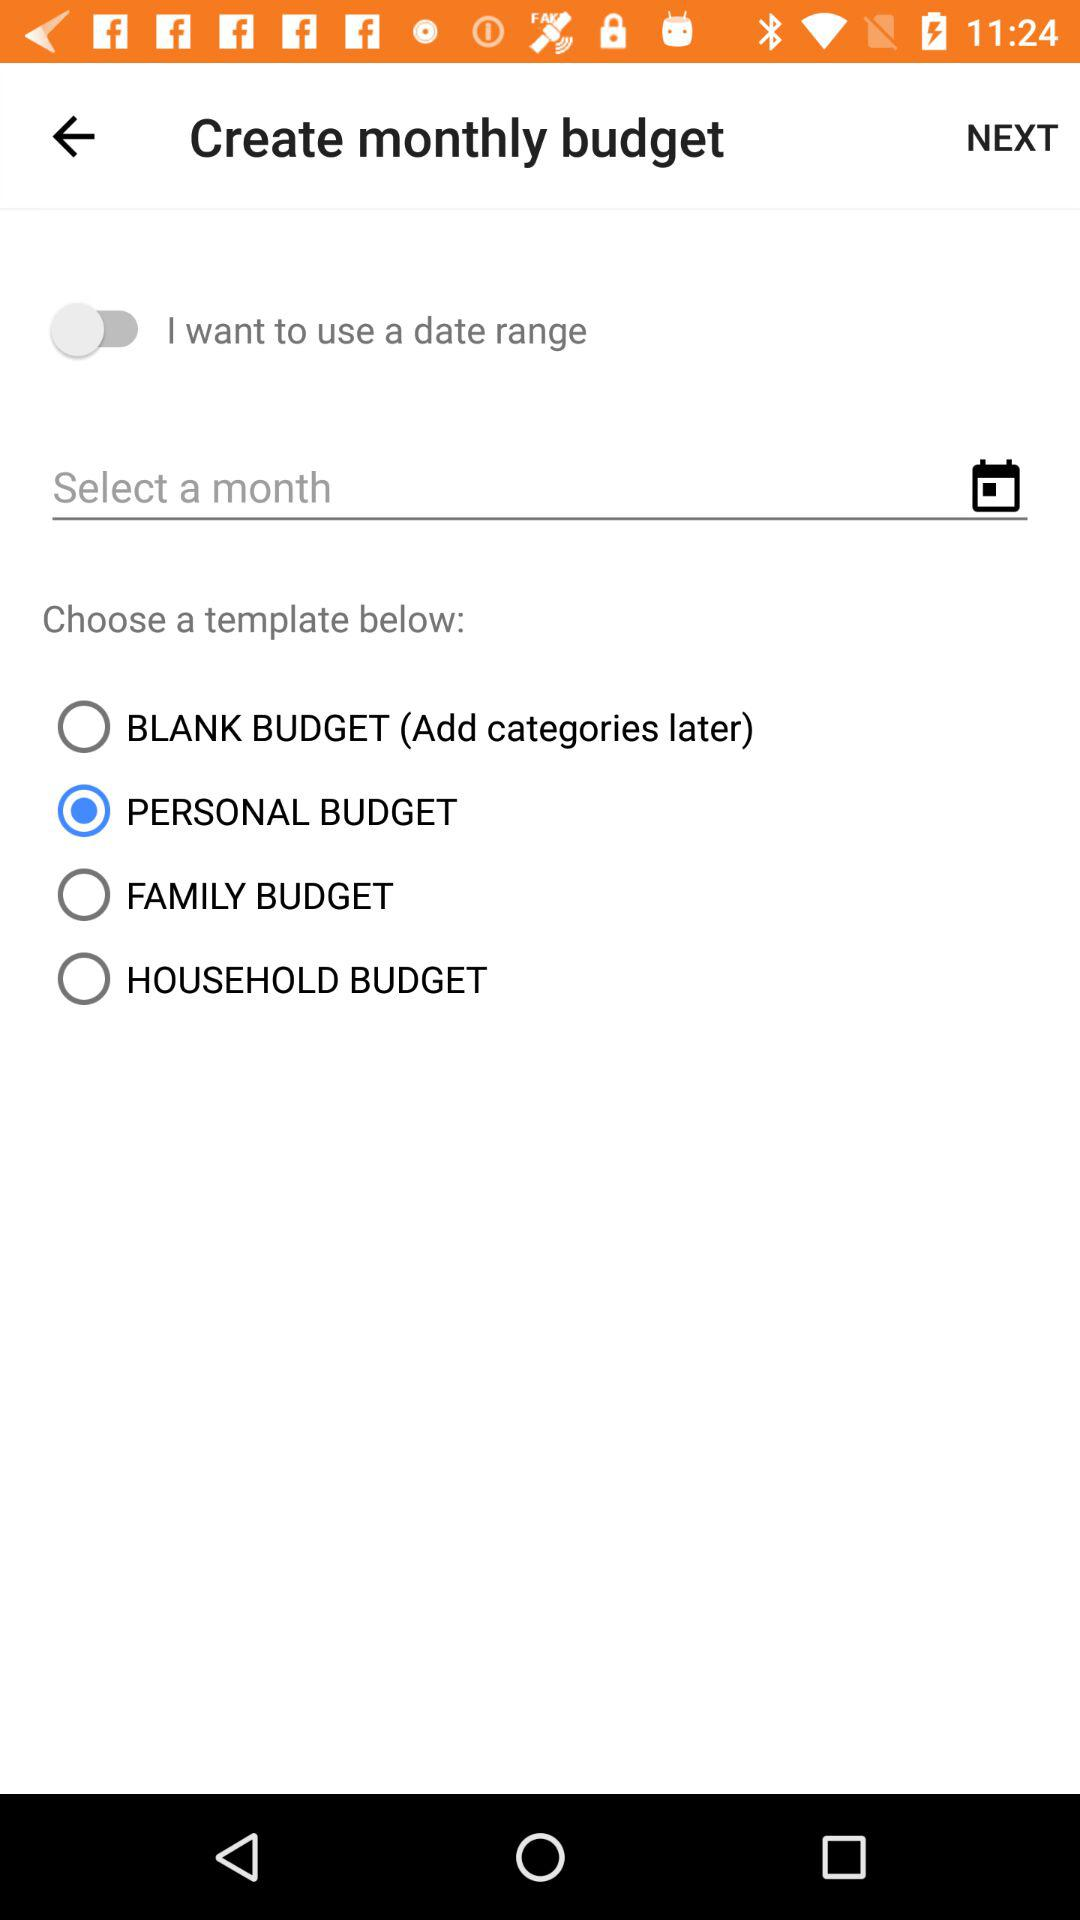What's the status of "I want to use a date range"? The status of "I want to use a date range" is "off". 